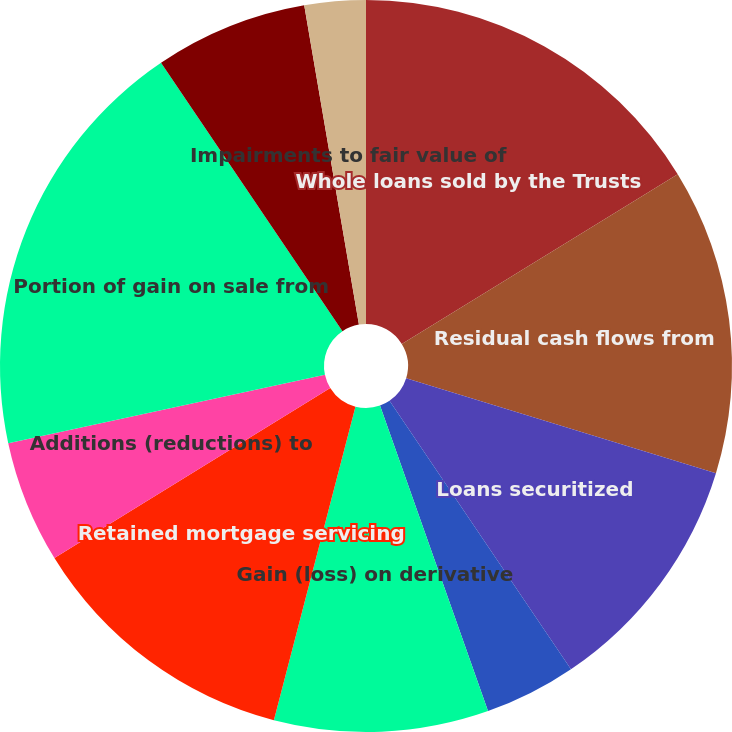<chart> <loc_0><loc_0><loc_500><loc_500><pie_chart><fcel>Whole loans sold by the Trusts<fcel>Residual cash flows from<fcel>Loans securitized<fcel>Sale of previously securitized<fcel>Gain (loss) on derivative<fcel>Retained mortgage servicing<fcel>Additions (reductions) to<fcel>Portion of gain on sale from<fcel>Changes in beneficial interest<fcel>Impairments to fair value of<nl><fcel>16.22%<fcel>13.51%<fcel>10.81%<fcel>4.05%<fcel>9.46%<fcel>12.16%<fcel>5.41%<fcel>18.92%<fcel>6.76%<fcel>2.7%<nl></chart> 